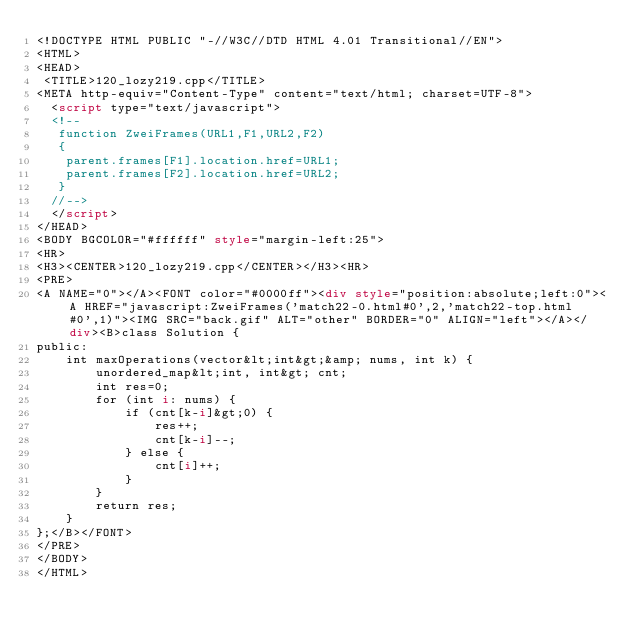Convert code to text. <code><loc_0><loc_0><loc_500><loc_500><_HTML_><!DOCTYPE HTML PUBLIC "-//W3C//DTD HTML 4.01 Transitional//EN">
<HTML>
<HEAD>
 <TITLE>120_lozy219.cpp</TITLE>
<META http-equiv="Content-Type" content="text/html; charset=UTF-8">
  <script type="text/javascript">
  <!--
   function ZweiFrames(URL1,F1,URL2,F2)
   {
    parent.frames[F1].location.href=URL1;
    parent.frames[F2].location.href=URL2;
   }
  //-->
  </script>
</HEAD>
<BODY BGCOLOR="#ffffff" style="margin-left:25">
<HR>
<H3><CENTER>120_lozy219.cpp</CENTER></H3><HR>
<PRE>
<A NAME="0"></A><FONT color="#0000ff"><div style="position:absolute;left:0"><A HREF="javascript:ZweiFrames('match22-0.html#0',2,'match22-top.html#0',1)"><IMG SRC="back.gif" ALT="other" BORDER="0" ALIGN="left"></A></div><B>class Solution {
public:
    int maxOperations(vector&lt;int&gt;&amp; nums, int k) {
        unordered_map&lt;int, int&gt; cnt;
        int res=0;
        for (int i: nums) {
            if (cnt[k-i]&gt;0) {
                res++;
                cnt[k-i]--;
            } else {
                cnt[i]++;
            }
        }
        return res;
    }
};</B></FONT>
</PRE>
</BODY>
</HTML>
</code> 